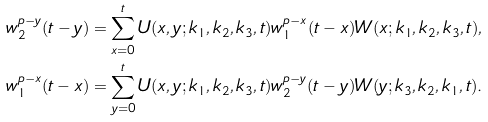<formula> <loc_0><loc_0><loc_500><loc_500>w _ { 2 } ^ { p - y } ( t - y ) & = \sum _ { x = 0 } ^ { t } U ( x , y ; k _ { 1 } , k _ { 2 } , k _ { 3 } , t ) w _ { 1 } ^ { p - x } ( t - x ) W ( x ; k _ { 1 } , k _ { 2 } , k _ { 3 } , t ) , \\ w _ { 1 } ^ { p - x } ( t - x ) & = \sum _ { y = 0 } ^ { t } U ( x , y ; k _ { 1 } , k _ { 2 } , k _ { 3 } , t ) w _ { 2 } ^ { p - y } ( t - y ) W ( y ; k _ { 3 } , k _ { 2 } , k _ { 1 } , t ) .</formula> 